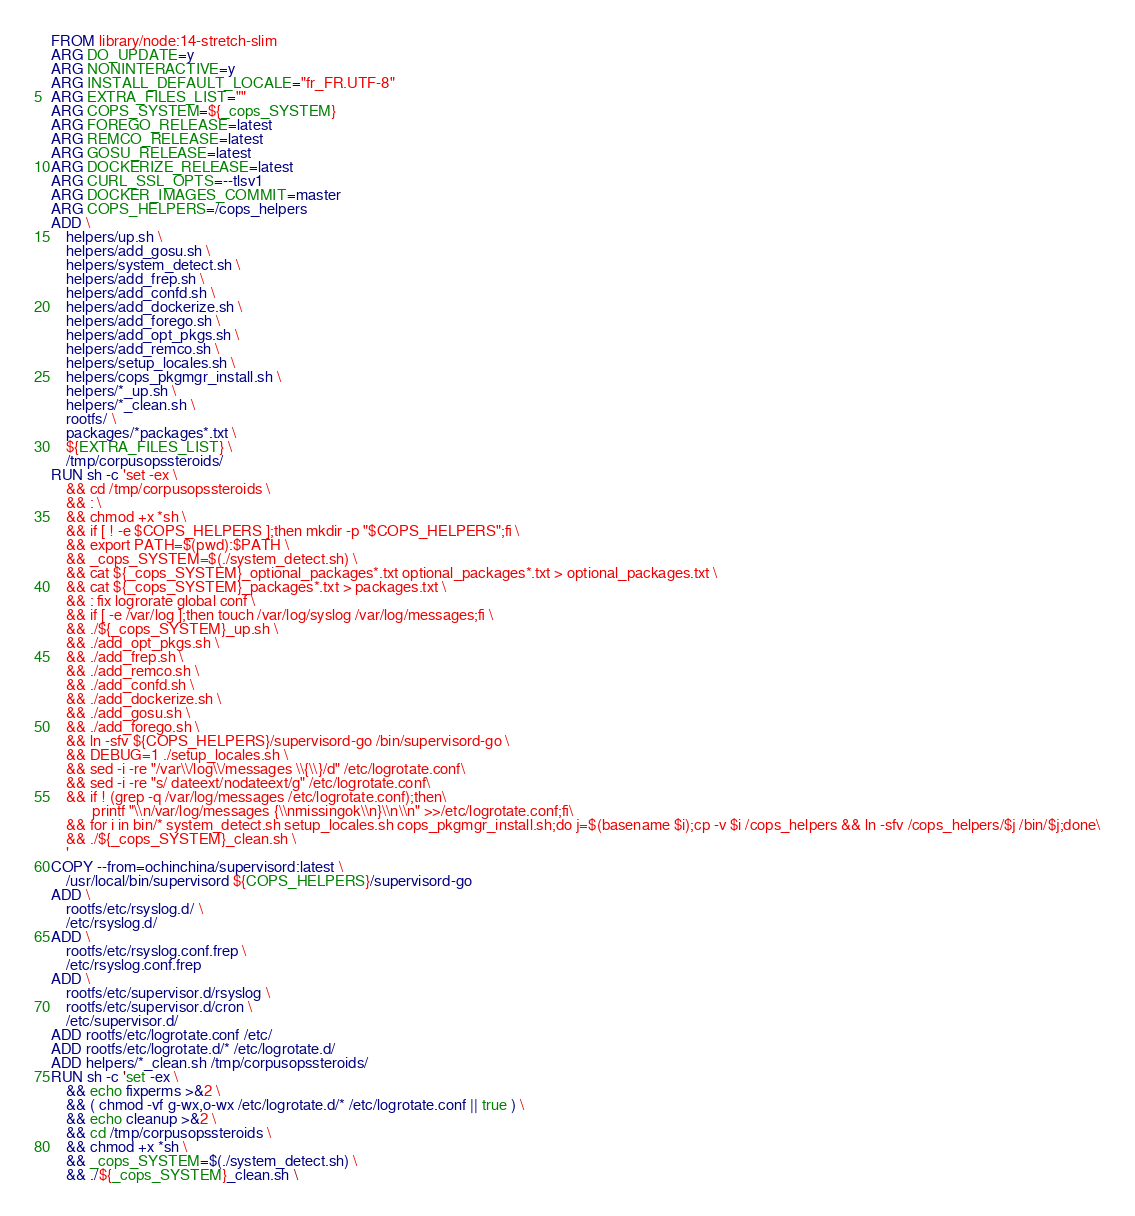Convert code to text. <code><loc_0><loc_0><loc_500><loc_500><_Dockerfile_>FROM library/node:14-stretch-slim
ARG DO_UPDATE=y
ARG NONINTERACTIVE=y
ARG INSTALL_DEFAULT_LOCALE="fr_FR.UTF-8"
ARG EXTRA_FILES_LIST=""
ARG COPS_SYSTEM=${_cops_SYSTEM}
ARG FOREGO_RELEASE=latest
ARG REMCO_RELEASE=latest
ARG GOSU_RELEASE=latest
ARG DOCKERIZE_RELEASE=latest
ARG CURL_SSL_OPTS=--tlsv1
ARG DOCKER_IMAGES_COMMIT=master
ARG COPS_HELPERS=/cops_helpers
ADD \
    helpers/up.sh \
    helpers/add_gosu.sh \
    helpers/system_detect.sh \
    helpers/add_frep.sh \
    helpers/add_confd.sh \
    helpers/add_dockerize.sh \
    helpers/add_forego.sh \
    helpers/add_opt_pkgs.sh \
    helpers/add_remco.sh \
    helpers/setup_locales.sh \
    helpers/cops_pkgmgr_install.sh \
    helpers/*_up.sh \
    helpers/*_clean.sh \
    rootfs/ \
    packages/*packages*.txt \
    ${EXTRA_FILES_LIST} \
    /tmp/corpusopssteroids/
RUN sh -c 'set -ex \
    && cd /tmp/corpusopssteroids \
    && : \
    && chmod +x *sh \
    && if [ ! -e $COPS_HELPERS ];then mkdir -p "$COPS_HELPERS";fi \
    && export PATH=$(pwd):$PATH \
    && _cops_SYSTEM=$(./system_detect.sh) \
    && cat ${_cops_SYSTEM}_optional_packages*.txt optional_packages*.txt > optional_packages.txt \
    && cat ${_cops_SYSTEM}_packages*.txt > packages.txt \
    && : fix logrorate global conf \
    && if [ -e /var/log ];then touch /var/log/syslog /var/log/messages;fi \
    && ./${_cops_SYSTEM}_up.sh \
    && ./add_opt_pkgs.sh \
    && ./add_frep.sh \
    && ./add_remco.sh \
    && ./add_confd.sh \
    && ./add_dockerize.sh \
    && ./add_gosu.sh \
    && ./add_forego.sh \
    && ln -sfv ${COPS_HELPERS}/supervisord-go /bin/supervisord-go \
    && DEBUG=1 ./setup_locales.sh \
    && sed -i -re "/var\\/log\\/messages \\{\\}/d" /etc/logrotate.conf\
    && sed -i -re "s/ dateext/nodateext/g" /etc/logrotate.conf\
    && if ! (grep -q /var/log/messages /etc/logrotate.conf);then\
           printf "\\n/var/log/messages {\\nmissingok\\n}\\n\\n" >>/etc/logrotate.conf;fi\
    && for i in bin/* system_detect.sh setup_locales.sh cops_pkgmgr_install.sh;do j=$(basename $i);cp -v $i /cops_helpers && ln -sfv /cops_helpers/$j /bin/$j;done\
    && ./${_cops_SYSTEM}_clean.sh \
    '
COPY --from=ochinchina/supervisord:latest \
    /usr/local/bin/supervisord ${COPS_HELPERS}/supervisord-go
ADD \
    rootfs/etc/rsyslog.d/ \
    /etc/rsyslog.d/
ADD \
    rootfs/etc/rsyslog.conf.frep \
    /etc/rsyslog.conf.frep
ADD \
    rootfs/etc/supervisor.d/rsyslog \
    rootfs/etc/supervisor.d/cron \
    /etc/supervisor.d/
ADD rootfs/etc/logrotate.conf /etc/
ADD rootfs/etc/logrotate.d/* /etc/logrotate.d/
ADD helpers/*_clean.sh /tmp/corpusopssteroids/
RUN sh -c 'set -ex \
    && echo fixperms >&2 \
    && ( chmod -vf g-wx,o-wx /etc/logrotate.d/* /etc/logrotate.conf || true ) \
    && echo cleanup >&2 \
    && cd /tmp/corpusopssteroids \
    && chmod +x *sh \
    && _cops_SYSTEM=$(./system_detect.sh) \
    && ./${_cops_SYSTEM}_clean.sh \</code> 